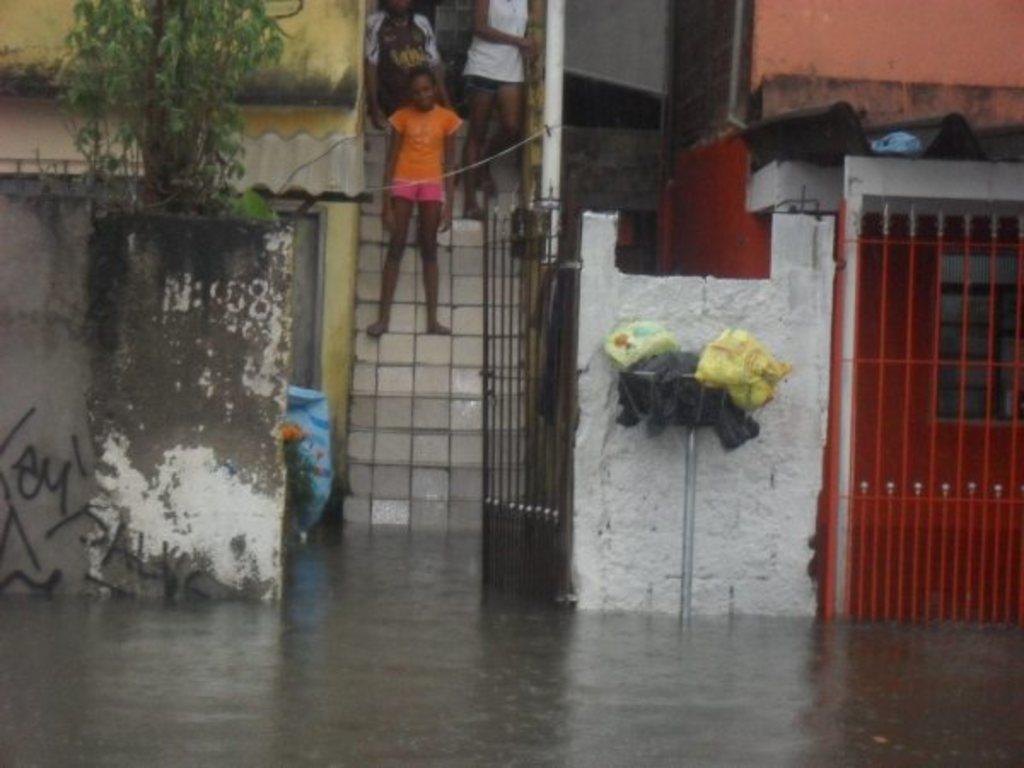What is in the foreground of the image? There is water in the foreground of the image. What type of structure can be seen in the image? There are metal gates in the image. Where are the people located in the image? People are standing on stairs in the image. What type of buildings can be seen in the image? There are houses visible in the image. How does the nerve affect the rainstorm in the image? A: There is no nerve or rainstorm present in the image, so this question cannot be answered. 